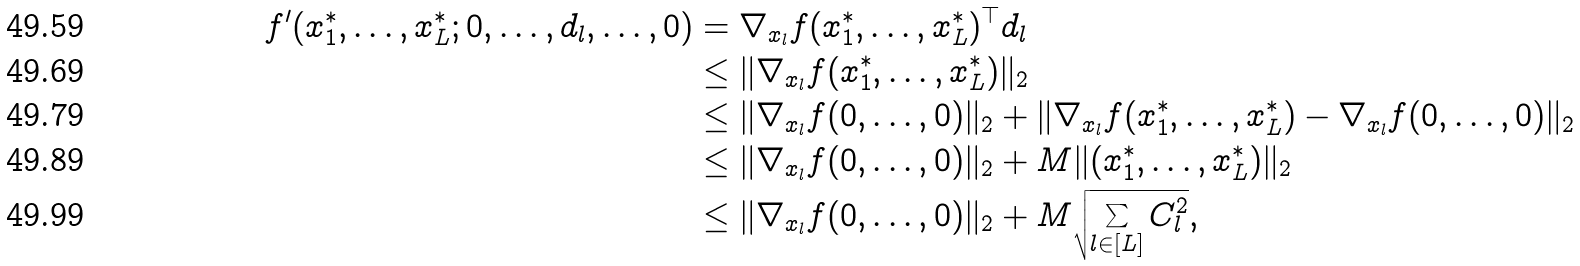Convert formula to latex. <formula><loc_0><loc_0><loc_500><loc_500>f ^ { \prime } ( x _ { 1 } ^ { * } , \dots , x _ { L } ^ { * } ; 0 , \dots , d _ { l } , \dots , 0 ) & = \nabla _ { x _ { l } } f ( x _ { 1 } ^ { * } , \dots , x _ { L } ^ { * } ) ^ { \top } d _ { l } \\ & \leq \| \nabla _ { x _ { l } } f ( x _ { 1 } ^ { * } , \dots , x _ { L } ^ { * } ) \| _ { 2 } \\ & \leq \| \nabla _ { x _ { l } } f ( 0 , \dots , 0 ) \| _ { 2 } + \| \nabla _ { x _ { l } } f ( x _ { 1 } ^ { * } , \dots , x _ { L } ^ { * } ) - \nabla _ { x _ { l } } f ( 0 , \dots , 0 ) \| _ { 2 } \\ & \leq \| \nabla _ { x _ { l } } f ( 0 , \dots , 0 ) \| _ { 2 } + M \| ( x _ { 1 } ^ { * } , \dots , x _ { L } ^ { * } ) \| _ { 2 } \\ & \leq \| \nabla _ { x _ { l } } f ( 0 , \dots , 0 ) \| _ { 2 } + M \sqrt { \sum _ { l \in [ L ] } C _ { l } ^ { 2 } } ,</formula> 